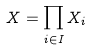Convert formula to latex. <formula><loc_0><loc_0><loc_500><loc_500>X = \prod _ { i \in I } X _ { i }</formula> 